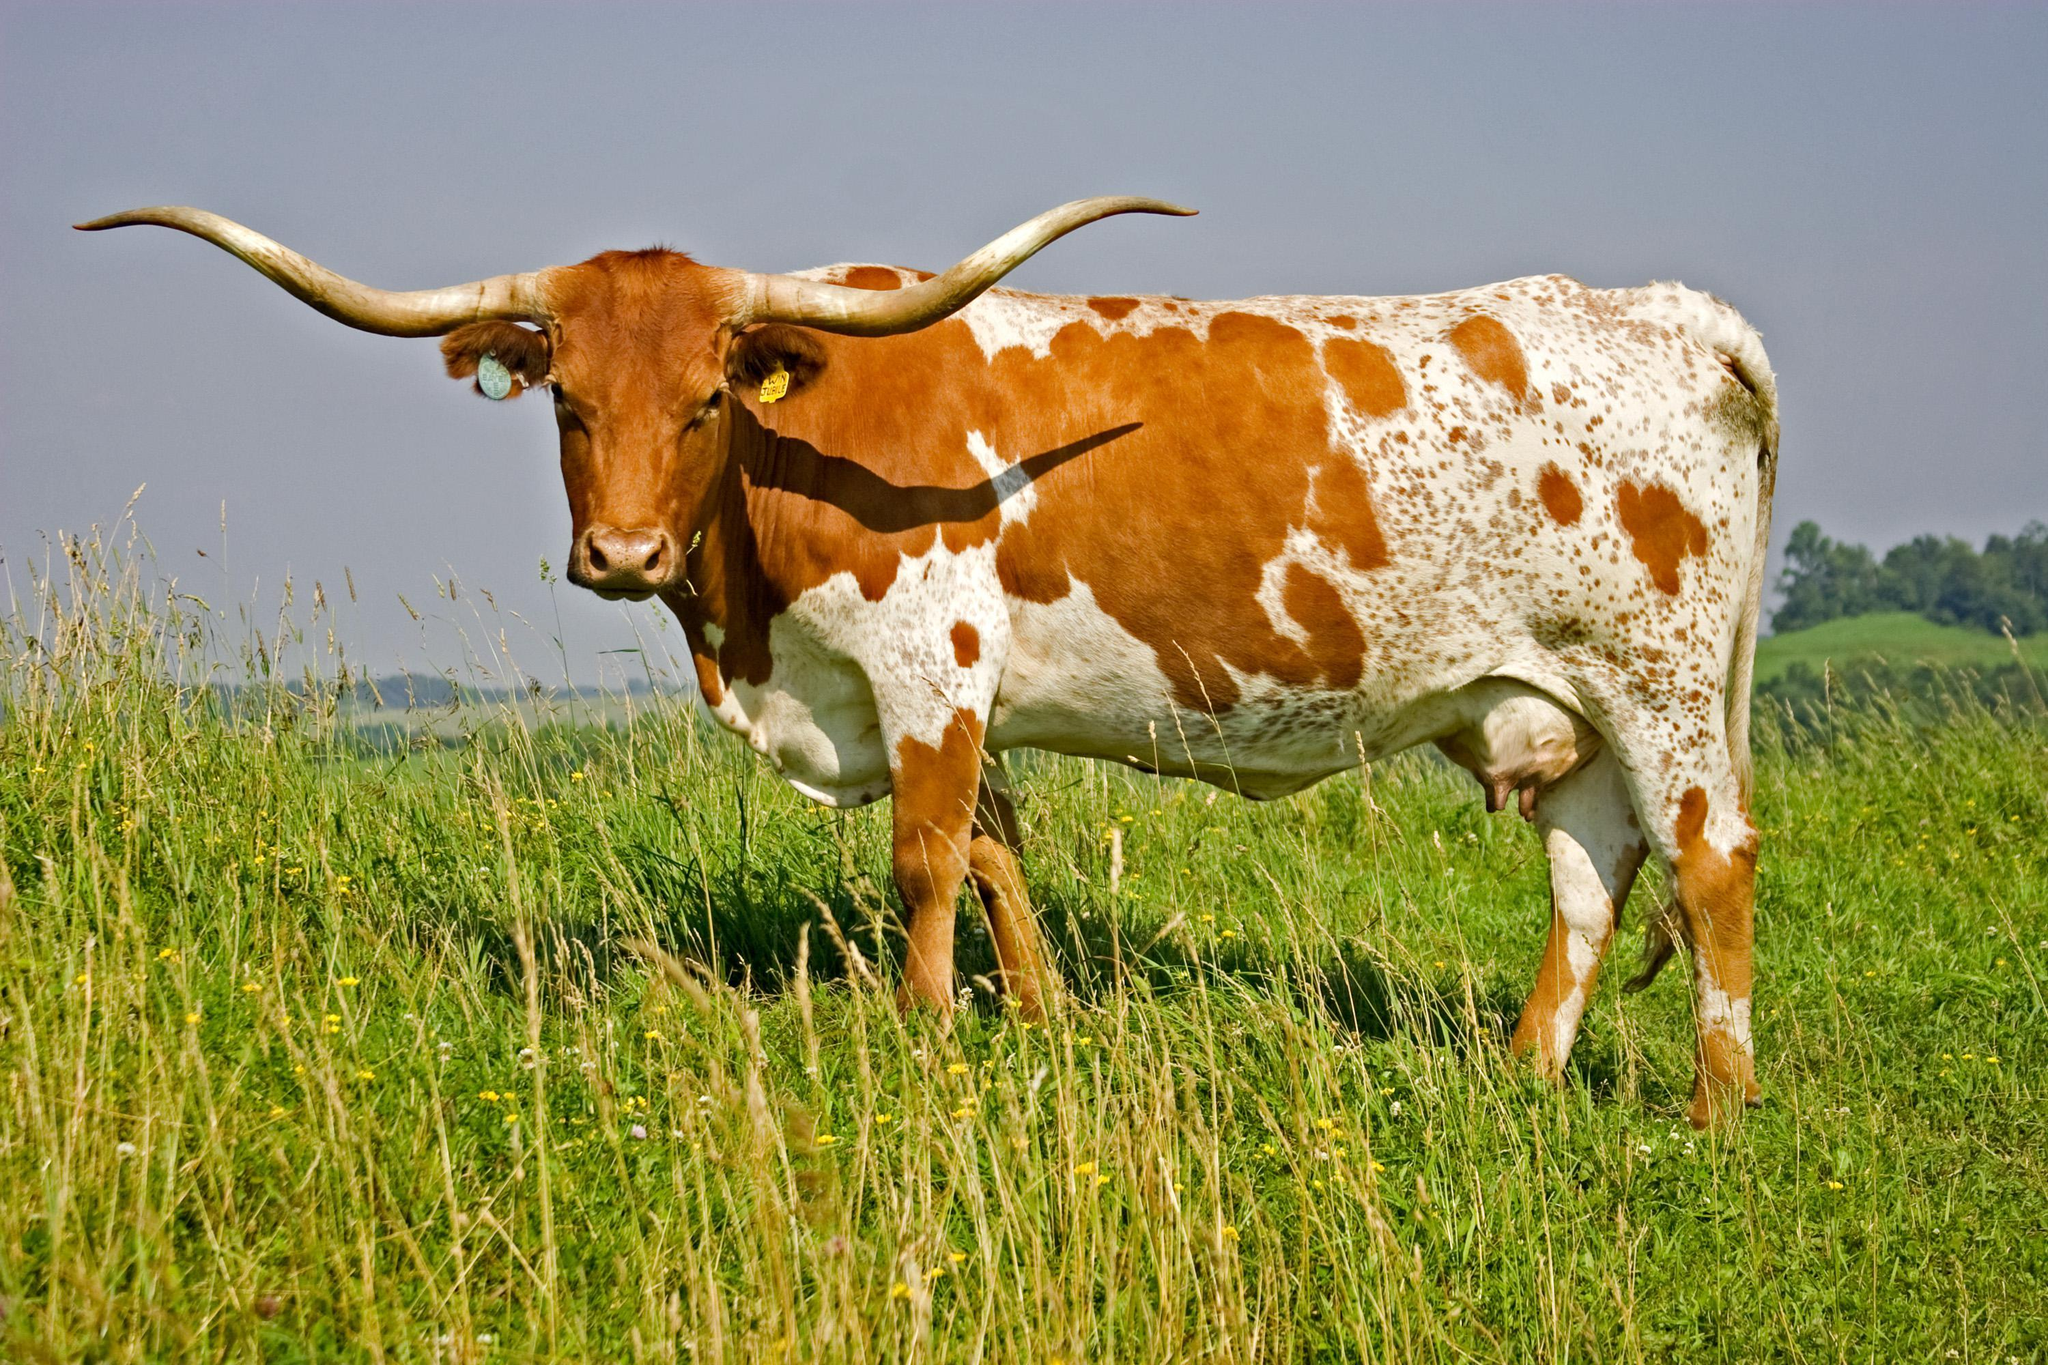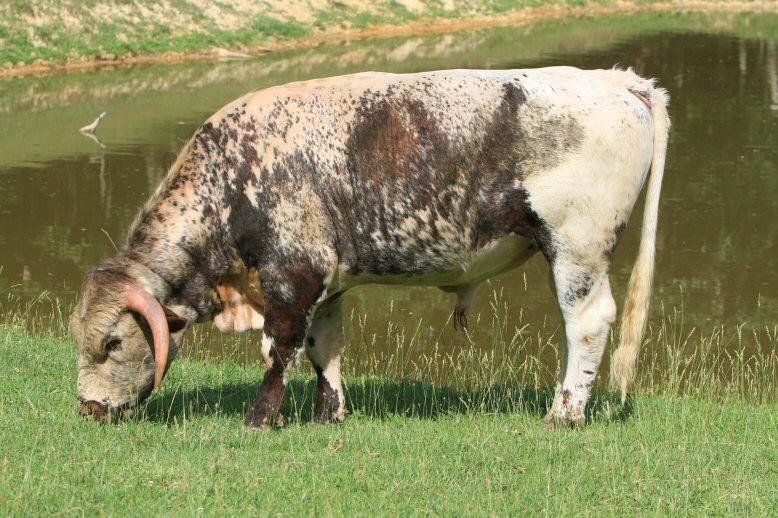The first image is the image on the left, the second image is the image on the right. Considering the images on both sides, is "Each image contains one hooved animal standing in profile, each animal is an adult cow with horns, and the animals on the left and right have their bodies turned in the same direction." valid? Answer yes or no. Yes. The first image is the image on the left, the second image is the image on the right. For the images shown, is this caption "One large animal is eating grass near a pond." true? Answer yes or no. Yes. 